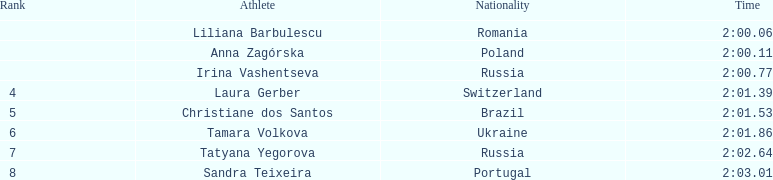After irina vashentseva, which south american nation was positioned? Brazil. 